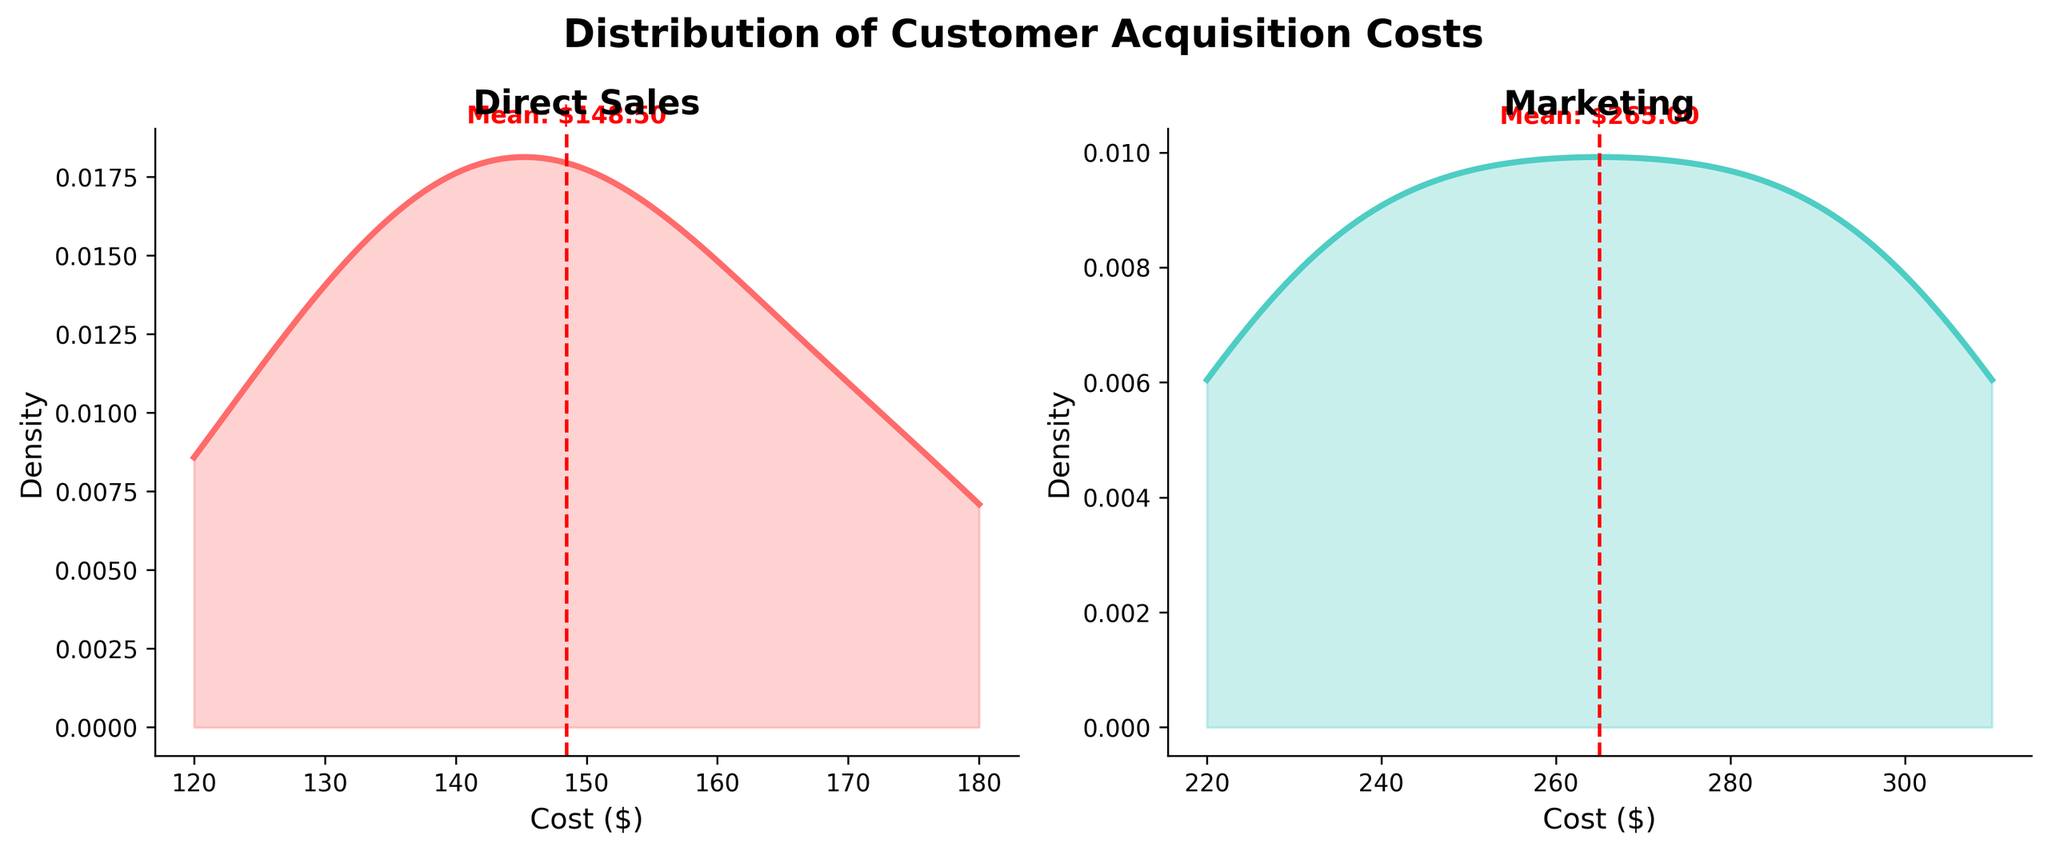What is the title of the figure? The title is displayed at the top center of the figure and reads 'Distribution of Customer Acquisition Costs'.
Answer: 'Distribution of Customer Acquisition Costs' Which channel has the lower average customer acquisition cost? The average customer acquisition costs are indicated by the red dashed lines on each subplot, and the text annotating these means shows that Direct Sales has a lower mean cost compared to Marketing.
Answer: Direct Sales What is the average customer acquisition cost for the Marketing channel? The red dashed line and the text annotation on the Marketing subplot show the average cost. It reads 'Mean: $265.00'.
Answer: $265.00 Is there more variation in customer acquisition costs for the Marketing or Direct Sales channel? By observing the density plots, the Marketing channel has a wider spread, indicating more variation compared to the Direct Sales channel.
Answer: Marketing How many subplots are depicted in the figure? There are two subplots side by side, one for Direct Sales and one for Marketing.
Answer: Two Between which cost values does the density of the Direct Sales customer acquisition cost mostly lie? By looking at the high-density regions of the Direct Sales density plot, the costs mostly lie between approximately $120 and $180.
Answer: $120 and $180 What color represents the Direct Sales channel in the figure? The Direct Sales density plot is filled with a pink color as shown in the figure.
Answer: Pink What statistical method is used to generate the density plots in the figure? The figure uses Gaussian Kernel Density Estimation (KDE) to generate the density plots, inferred from the smooth curves representing the distribution of costs.
Answer: Gaussian Kernel Density Estimation Are there any cost values where the density is zero for both channels? By examining the density plots, it can be observed that there are no overlapping regions with zero density for both channels.
Answer: No Which channel has the higher peak density value? The peak of the density plot for Direct Sales is higher compared to the peak for Marketing, indicating a higher peak density.
Answer: Direct Sales 